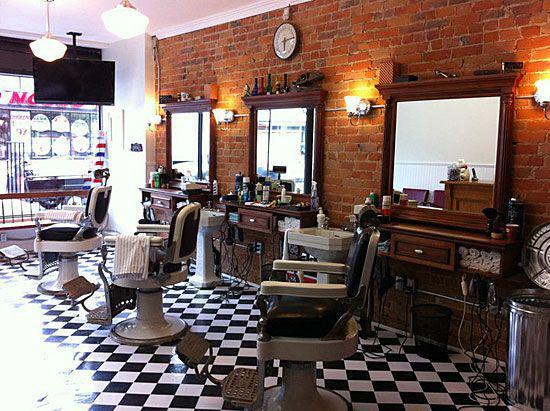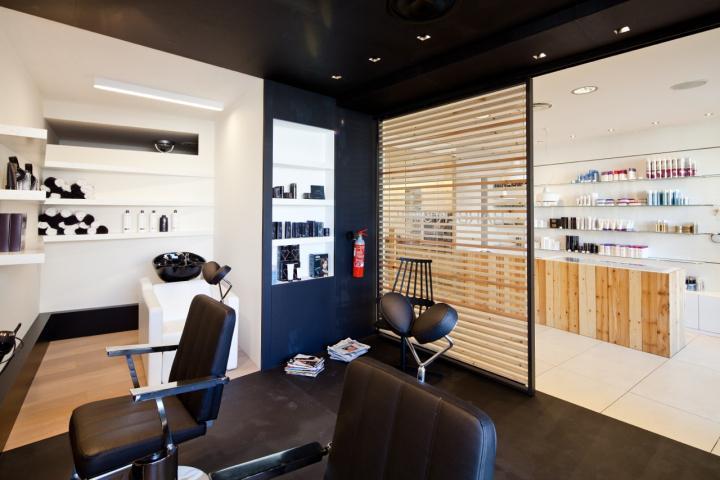The first image is the image on the left, the second image is the image on the right. For the images displayed, is the sentence "The chairs on the right side are white and black." factually correct? Answer yes or no. No. 